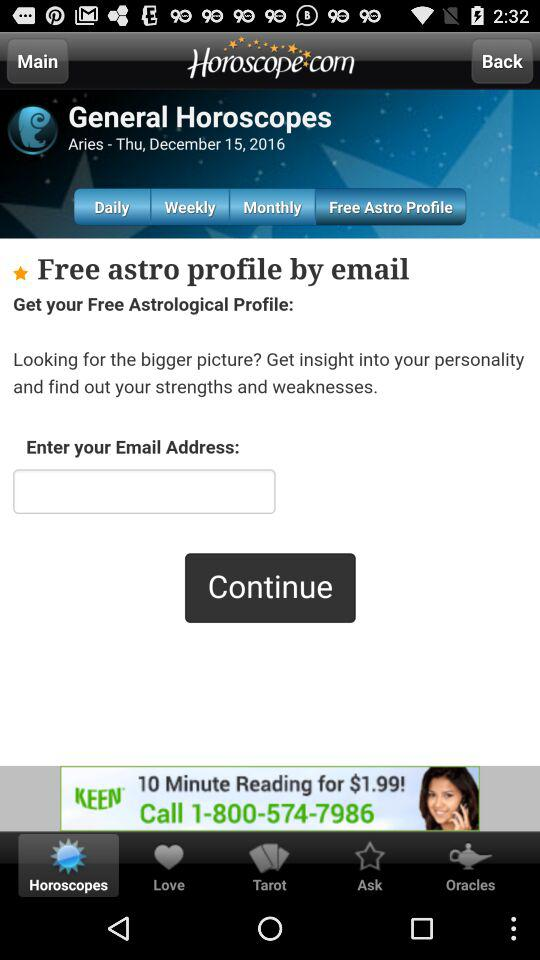What is the day on mentioned date? The day is Thursday. 